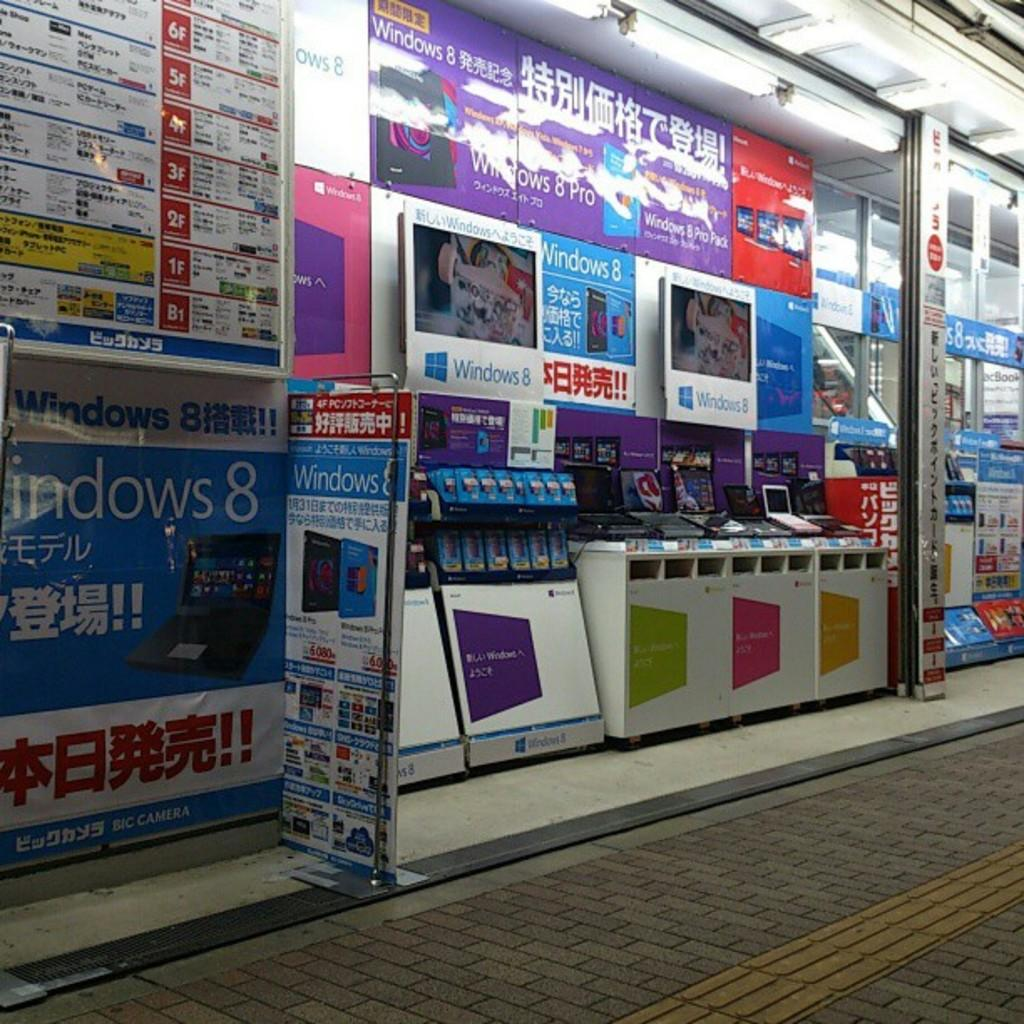What type of objects can be seen in the image that are related to advertising or displaying information? There are many boards and banners in the image. What type of surface can be seen in the image that is used for transportation? There is a road visible in the image. What type of electronic devices can be seen in the image? Laptops are displayed in the image. What type of lighting can be seen in the background of the image? Ceiling lights are present in the background of the image. Where is the mailbox located in the image? There is no mailbox present in the image. What type of park can be seen in the background of the image? There is no park present in the image. 